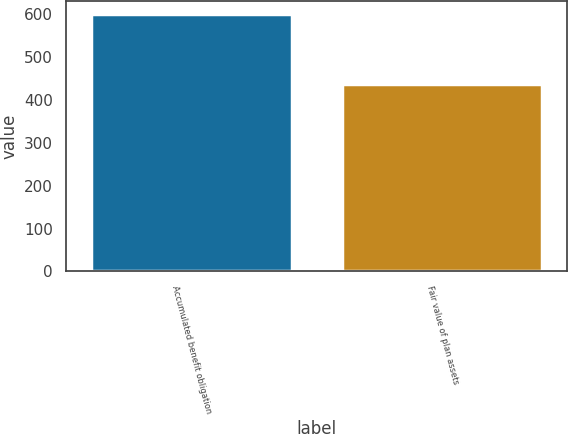Convert chart. <chart><loc_0><loc_0><loc_500><loc_500><bar_chart><fcel>Accumulated benefit obligation<fcel>Fair value of plan assets<nl><fcel>600.1<fcel>435.3<nl></chart> 